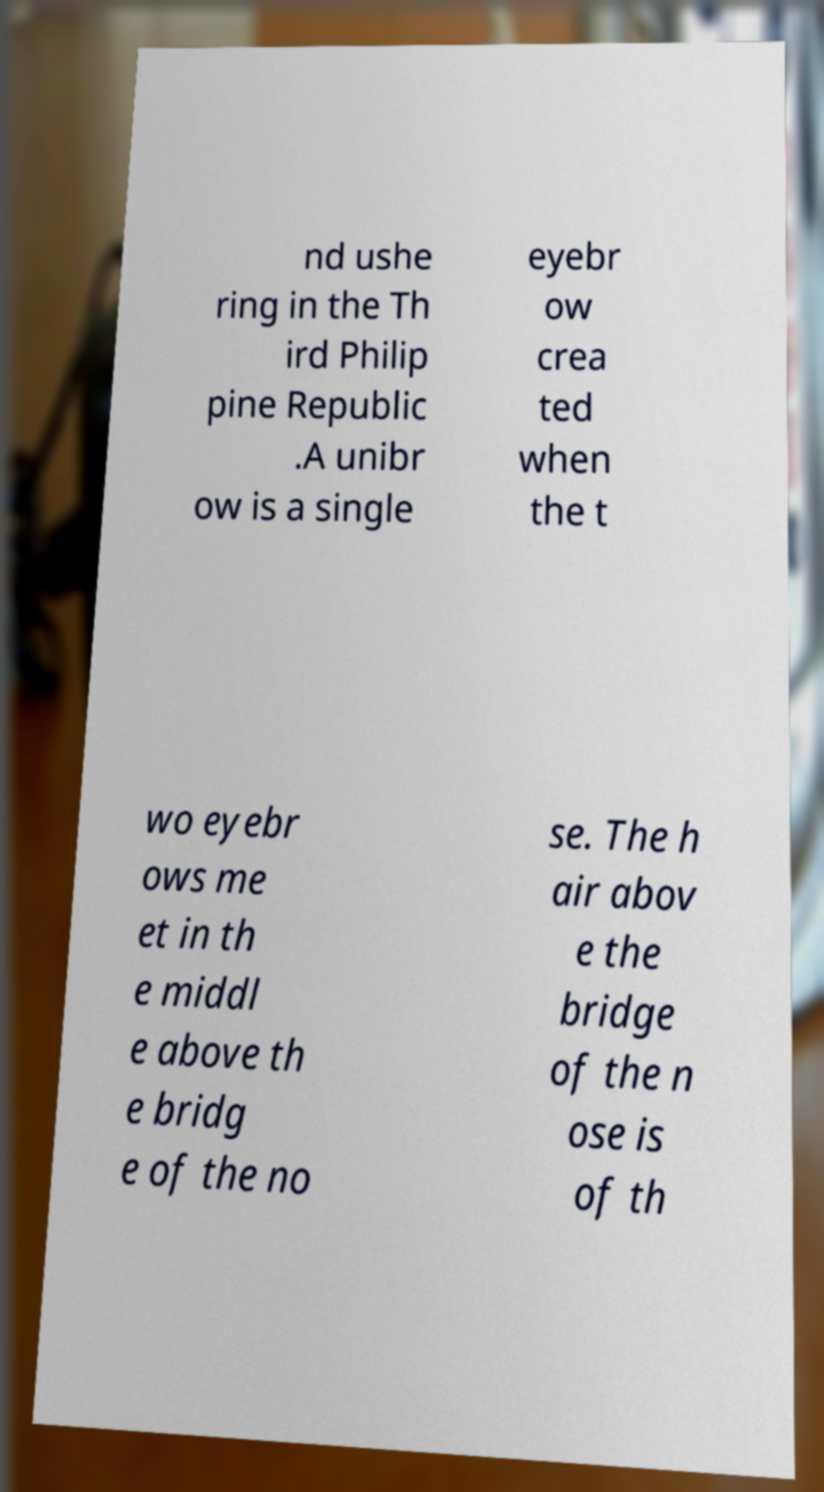Could you assist in decoding the text presented in this image and type it out clearly? nd ushe ring in the Th ird Philip pine Republic .A unibr ow is a single eyebr ow crea ted when the t wo eyebr ows me et in th e middl e above th e bridg e of the no se. The h air abov e the bridge of the n ose is of th 